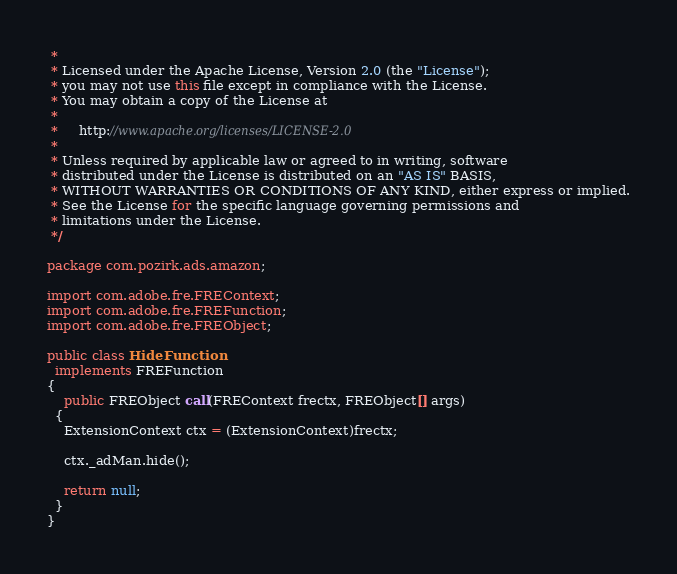Convert code to text. <code><loc_0><loc_0><loc_500><loc_500><_Java_> *
 * Licensed under the Apache License, Version 2.0 (the "License");
 * you may not use this file except in compliance with the License.
 * You may obtain a copy of the License at
 *
 *     http://www.apache.org/licenses/LICENSE-2.0
 *
 * Unless required by applicable law or agreed to in writing, software
 * distributed under the License is distributed on an "AS IS" BASIS,
 * WITHOUT WARRANTIES OR CONDITIONS OF ANY KIND, either express or implied.
 * See the License for the specific language governing permissions and
 * limitations under the License.
 */

package com.pozirk.ads.amazon;

import com.adobe.fre.FREContext;
import com.adobe.fre.FREFunction;
import com.adobe.fre.FREObject;

public class HideFunction
  implements FREFunction
{
	public FREObject call(FREContext frectx, FREObject[] args)
  {
  	ExtensionContext ctx = (ExtensionContext)frectx;

  	ctx._adMan.hide();

  	return null;
  }
}</code> 